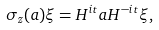Convert formula to latex. <formula><loc_0><loc_0><loc_500><loc_500>\sigma _ { z } ( a ) \xi = H ^ { i t } a H ^ { - i t } \xi ,</formula> 